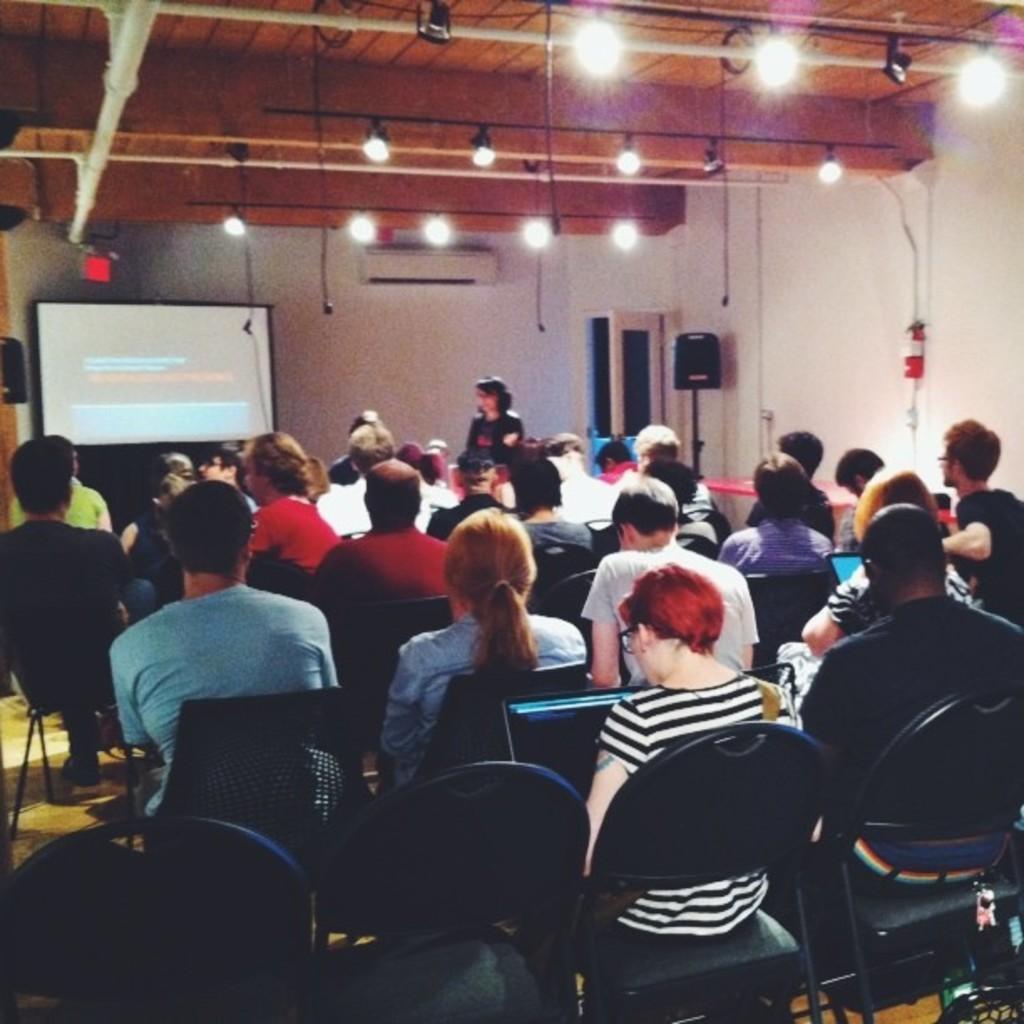Please provide a concise description of this image. In this image I can see there are the group of people sitting on chair and i can see a woman standing in front of screen ,and the screen visible in the middle and I can see window , stand and lights attached to the roof visible in the middle. 